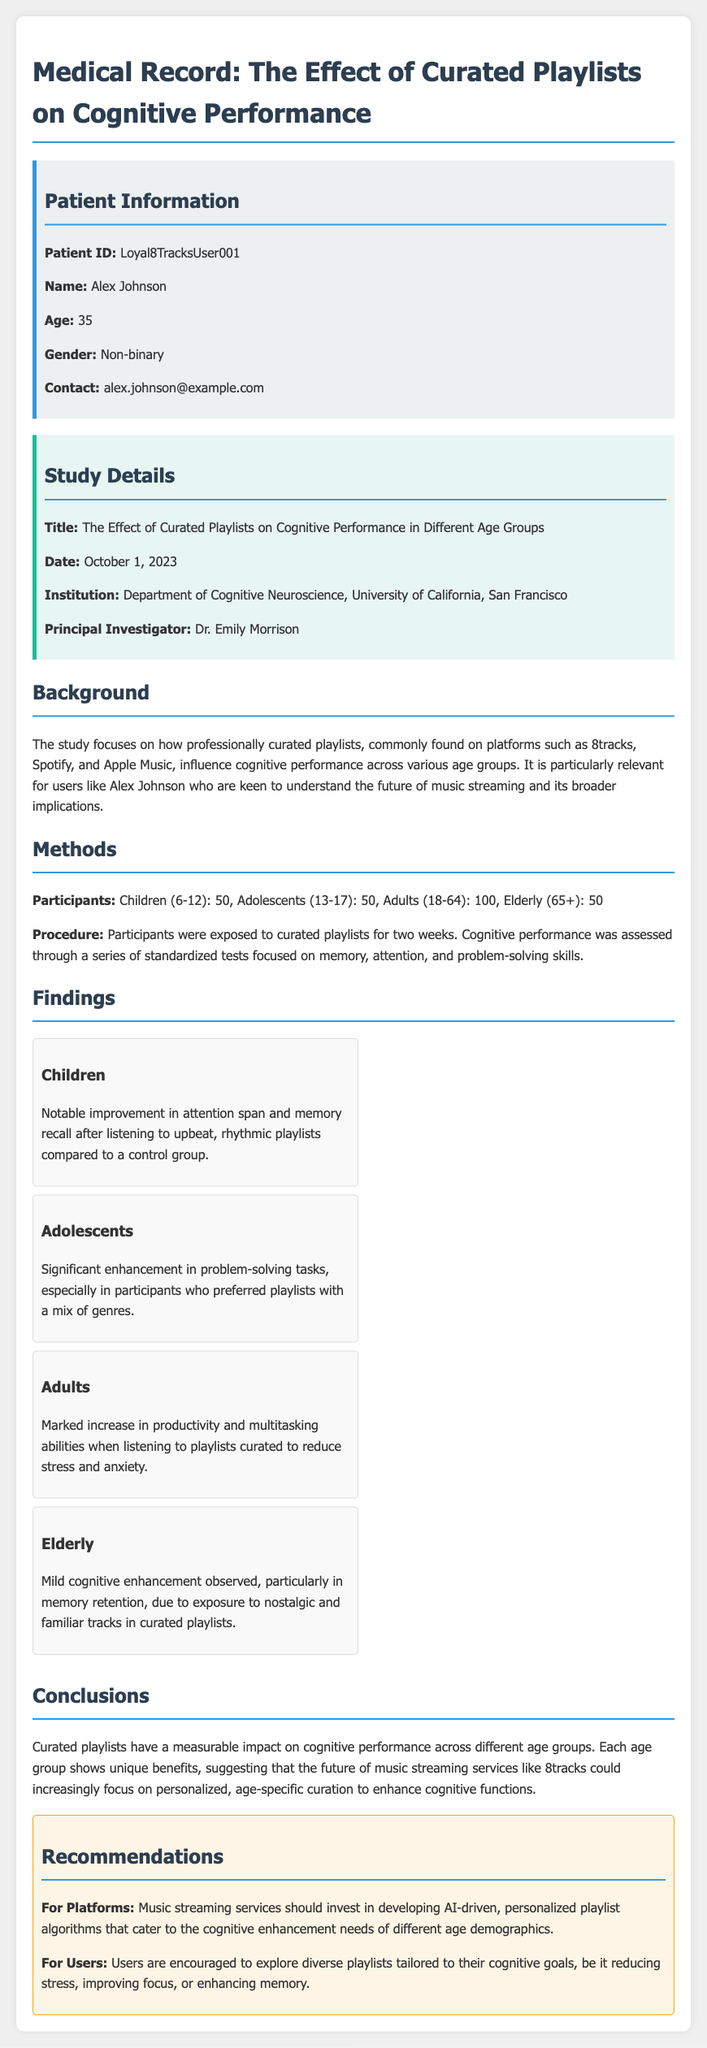What is the patient ID? The patient ID is provided in the patient information section of the document.
Answer: Loyal8TracksUser001 Who is the principal investigator? The principal investigator is mentioned in the study details section.
Answer: Dr. Emily Morrison How many adults participated in the study? The total number of adults participating is specified in the methods section.
Answer: 100 What was the date of the study? The date of the study is listed under study details.
Answer: October 1, 2023 What cognitive skill showed notable improvement in children? The cognitive skill identified for children is mentioned in their findings section.
Answer: Attention span What type of playlists improved productivity for adults? The type of playlists referenced for adults is found in the findings section.
Answer: Curated to reduce stress and anxiety How many participants were in the elderly group? The number of elderly participants is stated in the methods section.
Answer: 50 What background information is relevant to the study? The background information highlights the relevance of curated playlists, which is described in the dedicated section.
Answer: Influence on cognitive performance across age groups What recommendation is made for users? The recommendations section provides guidance for users based on study findings.
Answer: Explore diverse playlists tailored to cognitive goals 